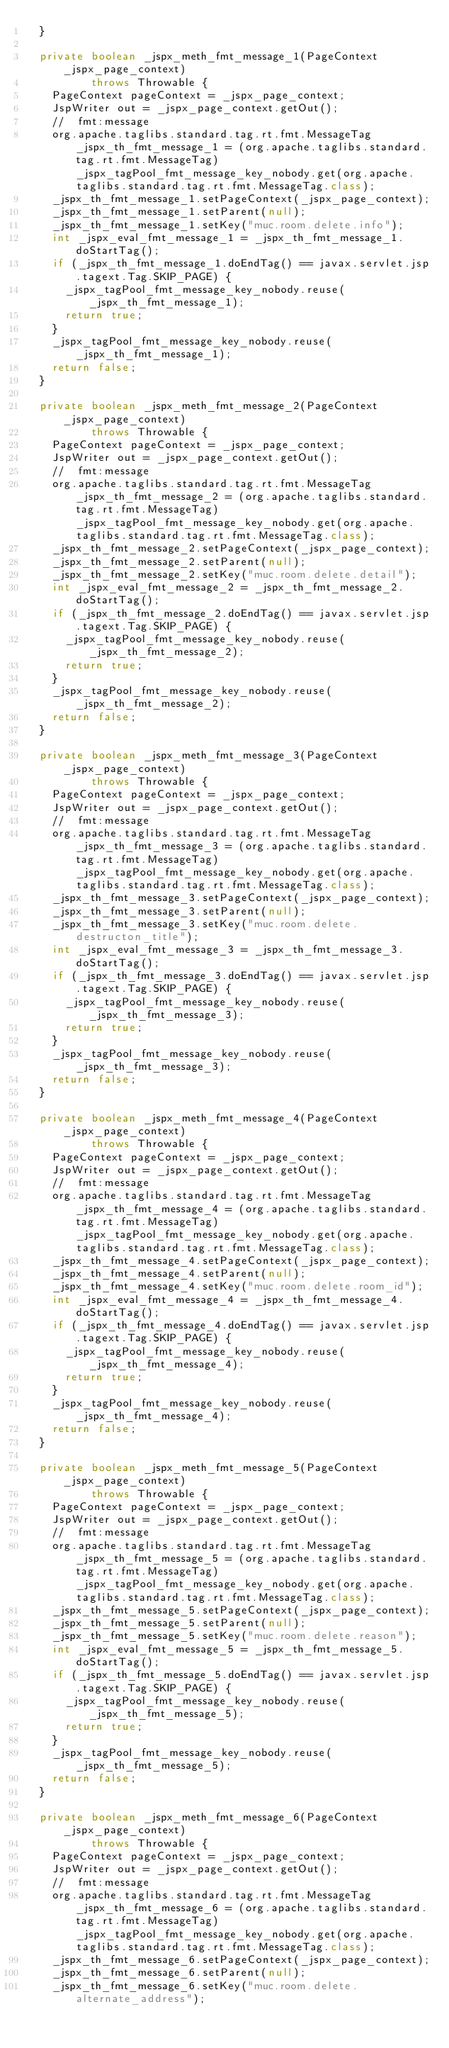Convert code to text. <code><loc_0><loc_0><loc_500><loc_500><_Java_>  }

  private boolean _jspx_meth_fmt_message_1(PageContext _jspx_page_context)
          throws Throwable {
    PageContext pageContext = _jspx_page_context;
    JspWriter out = _jspx_page_context.getOut();
    //  fmt:message
    org.apache.taglibs.standard.tag.rt.fmt.MessageTag _jspx_th_fmt_message_1 = (org.apache.taglibs.standard.tag.rt.fmt.MessageTag) _jspx_tagPool_fmt_message_key_nobody.get(org.apache.taglibs.standard.tag.rt.fmt.MessageTag.class);
    _jspx_th_fmt_message_1.setPageContext(_jspx_page_context);
    _jspx_th_fmt_message_1.setParent(null);
    _jspx_th_fmt_message_1.setKey("muc.room.delete.info");
    int _jspx_eval_fmt_message_1 = _jspx_th_fmt_message_1.doStartTag();
    if (_jspx_th_fmt_message_1.doEndTag() == javax.servlet.jsp.tagext.Tag.SKIP_PAGE) {
      _jspx_tagPool_fmt_message_key_nobody.reuse(_jspx_th_fmt_message_1);
      return true;
    }
    _jspx_tagPool_fmt_message_key_nobody.reuse(_jspx_th_fmt_message_1);
    return false;
  }

  private boolean _jspx_meth_fmt_message_2(PageContext _jspx_page_context)
          throws Throwable {
    PageContext pageContext = _jspx_page_context;
    JspWriter out = _jspx_page_context.getOut();
    //  fmt:message
    org.apache.taglibs.standard.tag.rt.fmt.MessageTag _jspx_th_fmt_message_2 = (org.apache.taglibs.standard.tag.rt.fmt.MessageTag) _jspx_tagPool_fmt_message_key_nobody.get(org.apache.taglibs.standard.tag.rt.fmt.MessageTag.class);
    _jspx_th_fmt_message_2.setPageContext(_jspx_page_context);
    _jspx_th_fmt_message_2.setParent(null);
    _jspx_th_fmt_message_2.setKey("muc.room.delete.detail");
    int _jspx_eval_fmt_message_2 = _jspx_th_fmt_message_2.doStartTag();
    if (_jspx_th_fmt_message_2.doEndTag() == javax.servlet.jsp.tagext.Tag.SKIP_PAGE) {
      _jspx_tagPool_fmt_message_key_nobody.reuse(_jspx_th_fmt_message_2);
      return true;
    }
    _jspx_tagPool_fmt_message_key_nobody.reuse(_jspx_th_fmt_message_2);
    return false;
  }

  private boolean _jspx_meth_fmt_message_3(PageContext _jspx_page_context)
          throws Throwable {
    PageContext pageContext = _jspx_page_context;
    JspWriter out = _jspx_page_context.getOut();
    //  fmt:message
    org.apache.taglibs.standard.tag.rt.fmt.MessageTag _jspx_th_fmt_message_3 = (org.apache.taglibs.standard.tag.rt.fmt.MessageTag) _jspx_tagPool_fmt_message_key_nobody.get(org.apache.taglibs.standard.tag.rt.fmt.MessageTag.class);
    _jspx_th_fmt_message_3.setPageContext(_jspx_page_context);
    _jspx_th_fmt_message_3.setParent(null);
    _jspx_th_fmt_message_3.setKey("muc.room.delete.destructon_title");
    int _jspx_eval_fmt_message_3 = _jspx_th_fmt_message_3.doStartTag();
    if (_jspx_th_fmt_message_3.doEndTag() == javax.servlet.jsp.tagext.Tag.SKIP_PAGE) {
      _jspx_tagPool_fmt_message_key_nobody.reuse(_jspx_th_fmt_message_3);
      return true;
    }
    _jspx_tagPool_fmt_message_key_nobody.reuse(_jspx_th_fmt_message_3);
    return false;
  }

  private boolean _jspx_meth_fmt_message_4(PageContext _jspx_page_context)
          throws Throwable {
    PageContext pageContext = _jspx_page_context;
    JspWriter out = _jspx_page_context.getOut();
    //  fmt:message
    org.apache.taglibs.standard.tag.rt.fmt.MessageTag _jspx_th_fmt_message_4 = (org.apache.taglibs.standard.tag.rt.fmt.MessageTag) _jspx_tagPool_fmt_message_key_nobody.get(org.apache.taglibs.standard.tag.rt.fmt.MessageTag.class);
    _jspx_th_fmt_message_4.setPageContext(_jspx_page_context);
    _jspx_th_fmt_message_4.setParent(null);
    _jspx_th_fmt_message_4.setKey("muc.room.delete.room_id");
    int _jspx_eval_fmt_message_4 = _jspx_th_fmt_message_4.doStartTag();
    if (_jspx_th_fmt_message_4.doEndTag() == javax.servlet.jsp.tagext.Tag.SKIP_PAGE) {
      _jspx_tagPool_fmt_message_key_nobody.reuse(_jspx_th_fmt_message_4);
      return true;
    }
    _jspx_tagPool_fmt_message_key_nobody.reuse(_jspx_th_fmt_message_4);
    return false;
  }

  private boolean _jspx_meth_fmt_message_5(PageContext _jspx_page_context)
          throws Throwable {
    PageContext pageContext = _jspx_page_context;
    JspWriter out = _jspx_page_context.getOut();
    //  fmt:message
    org.apache.taglibs.standard.tag.rt.fmt.MessageTag _jspx_th_fmt_message_5 = (org.apache.taglibs.standard.tag.rt.fmt.MessageTag) _jspx_tagPool_fmt_message_key_nobody.get(org.apache.taglibs.standard.tag.rt.fmt.MessageTag.class);
    _jspx_th_fmt_message_5.setPageContext(_jspx_page_context);
    _jspx_th_fmt_message_5.setParent(null);
    _jspx_th_fmt_message_5.setKey("muc.room.delete.reason");
    int _jspx_eval_fmt_message_5 = _jspx_th_fmt_message_5.doStartTag();
    if (_jspx_th_fmt_message_5.doEndTag() == javax.servlet.jsp.tagext.Tag.SKIP_PAGE) {
      _jspx_tagPool_fmt_message_key_nobody.reuse(_jspx_th_fmt_message_5);
      return true;
    }
    _jspx_tagPool_fmt_message_key_nobody.reuse(_jspx_th_fmt_message_5);
    return false;
  }

  private boolean _jspx_meth_fmt_message_6(PageContext _jspx_page_context)
          throws Throwable {
    PageContext pageContext = _jspx_page_context;
    JspWriter out = _jspx_page_context.getOut();
    //  fmt:message
    org.apache.taglibs.standard.tag.rt.fmt.MessageTag _jspx_th_fmt_message_6 = (org.apache.taglibs.standard.tag.rt.fmt.MessageTag) _jspx_tagPool_fmt_message_key_nobody.get(org.apache.taglibs.standard.tag.rt.fmt.MessageTag.class);
    _jspx_th_fmt_message_6.setPageContext(_jspx_page_context);
    _jspx_th_fmt_message_6.setParent(null);
    _jspx_th_fmt_message_6.setKey("muc.room.delete.alternate_address");</code> 